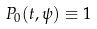<formula> <loc_0><loc_0><loc_500><loc_500>P _ { 0 } ( t , \psi ) \equiv 1</formula> 